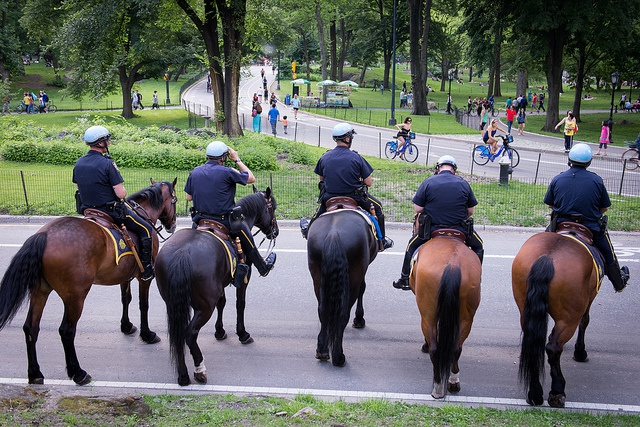Describe the objects in this image and their specific colors. I can see horse in black, maroon, purple, and brown tones, horse in black, maroon, gray, and brown tones, horse in black, purple, and gray tones, horse in black, brown, and maroon tones, and horse in black, gray, and purple tones in this image. 